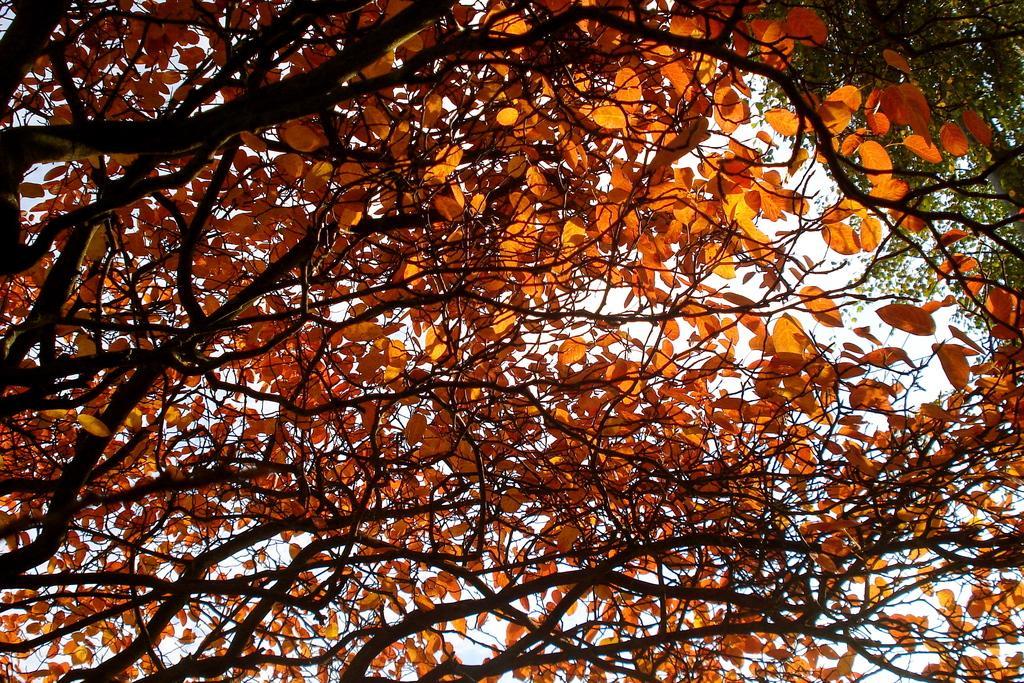Describe this image in one or two sentences. In this image there are trees with green and orange color leaves , and in the background there is sky. 